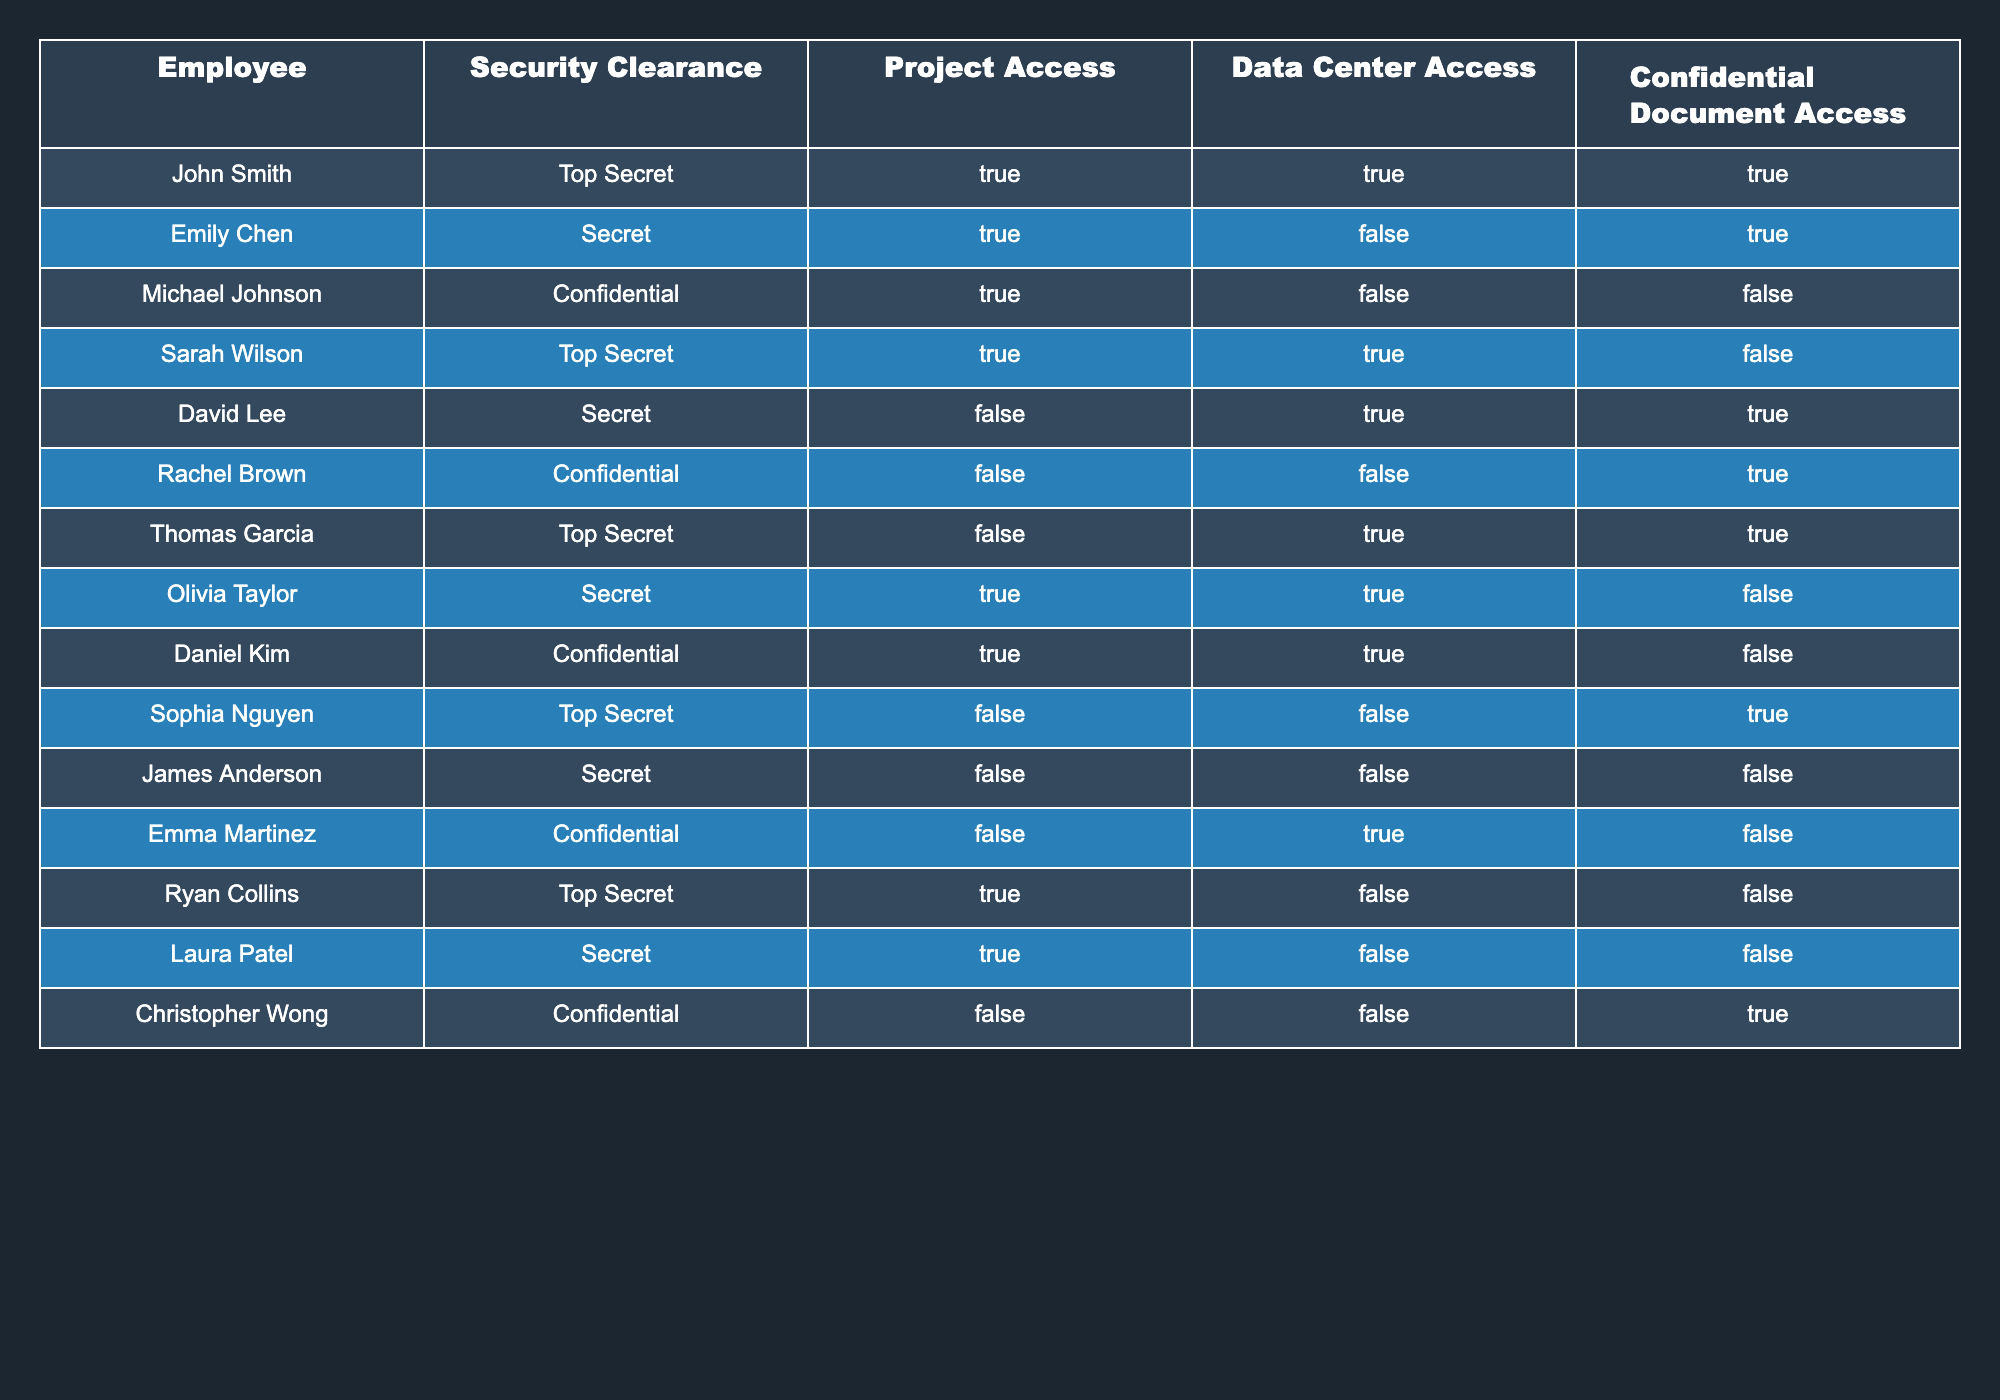What are the names of employees with a Top Secret clearance? From the table, we can directly see that John Smith, Sarah Wilson, Thomas Garcia, and Sophia Nguyen have a Top Secret clearance listed under the "Security Clearance" column.
Answer: John Smith, Sarah Wilson, Thomas Garcia, Sophia Nguyen How many employees have access to confidential documents? We can count the number of times "True" appears under the "Confidential Document Access" column. The employees Rachel Brown, Emily Chen, John Smith, and David Lee have "True" under this column. Therefore, there are 4 employees.
Answer: 4 Is David Lee allowed to access the data center? We can find David Lee in the table and see the "Data Center Access" column value for him. For David Lee, this value is "True", which means he is allowed to access the data center.
Answer: Yes Which employee has a Secret clearance and no access to confidential documents? By examining the table, we see that both Emily Chen and David Lee have a "Secret" security clearance. However, only David Lee does not have access to confidential documents (False).
Answer: David Lee What percentage of employees with a Top Secret clearance can access confidential documents? First, we need to identify the employees with Top Secret clearance: John Smith, Sarah Wilson, Thomas Garcia, and Sophia Nguyen (4 in total). Out of these, John Smith and Sophia Nguyen can access confidential documents (2 of them have "True"). The percentage is calculated by (2/4) * 100 = 50%.
Answer: 50% 